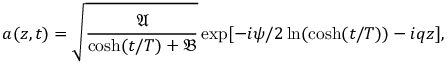Convert formula to latex. <formula><loc_0><loc_0><loc_500><loc_500>a ( z , t ) = \sqrt { \frac { \mathfrak { A } } { \cosh ( t / T ) + \mathfrak { B } } } \exp [ - i \psi / 2 \ln ( \cosh ( t / T ) ) - i q z ] ,</formula> 